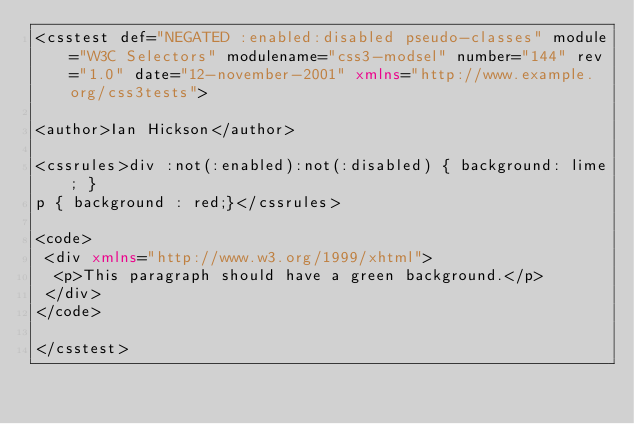Convert code to text. <code><loc_0><loc_0><loc_500><loc_500><_XML_><csstest def="NEGATED :enabled:disabled pseudo-classes" module="W3C Selectors" modulename="css3-modsel" number="144" rev="1.0" date="12-november-2001" xmlns="http://www.example.org/css3tests">

<author>Ian Hickson</author>

<cssrules>div :not(:enabled):not(:disabled) { background: lime; }
p { background : red;}</cssrules>

<code>
 <div xmlns="http://www.w3.org/1999/xhtml">
  <p>This paragraph should have a green background.</p>
 </div>
</code>

</csstest>
</code> 